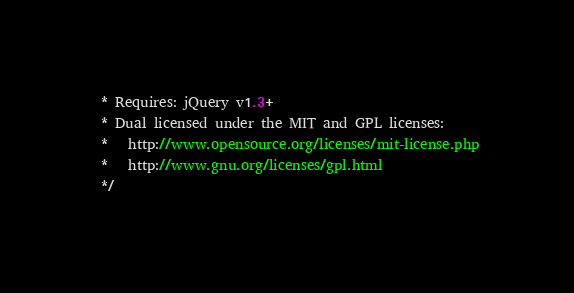<code> <loc_0><loc_0><loc_500><loc_500><_JavaScript_> * Requires: jQuery v1.3+
 * Dual licensed under the MIT and GPL licenses:
 *   http://www.opensource.org/licenses/mit-license.php
 *   http://www.gnu.org/licenses/gpl.html
 */</code> 